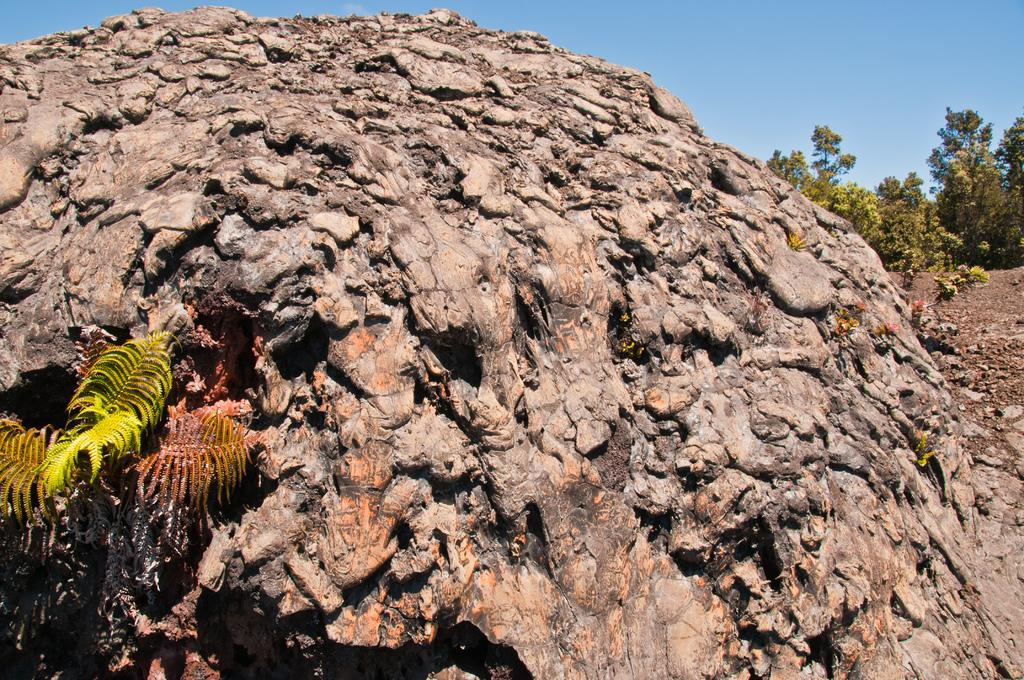What is the main subject of the image? There is a rock in the image. What can be seen in the background of the image? There are trees in the background of the image. What color is the sky in the image? The sky is blue in color. How many women are present in the image? There are no women present in the image; it features a rock, trees, and a blue sky. 